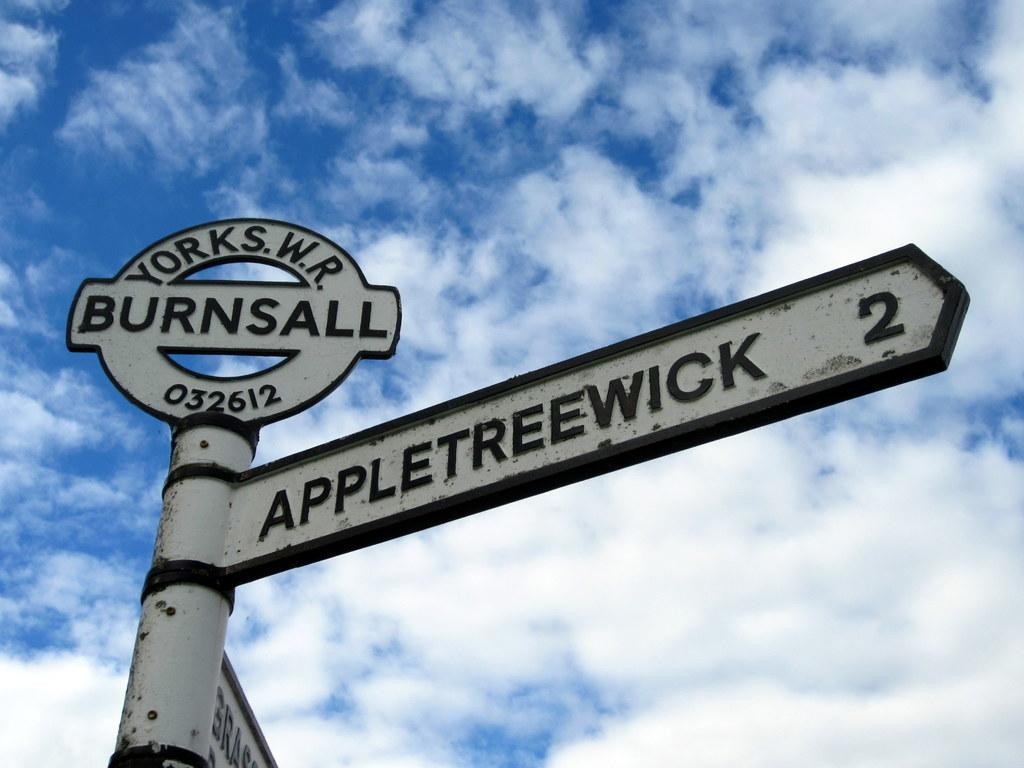Provide a one-sentence caption for the provided image. An antique street sign in Burnsall featuring Appletreewick street. 